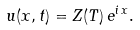Convert formula to latex. <formula><loc_0><loc_0><loc_500><loc_500>u ( x , t ) = Z ( T ) \, e ^ { i \, x } .</formula> 